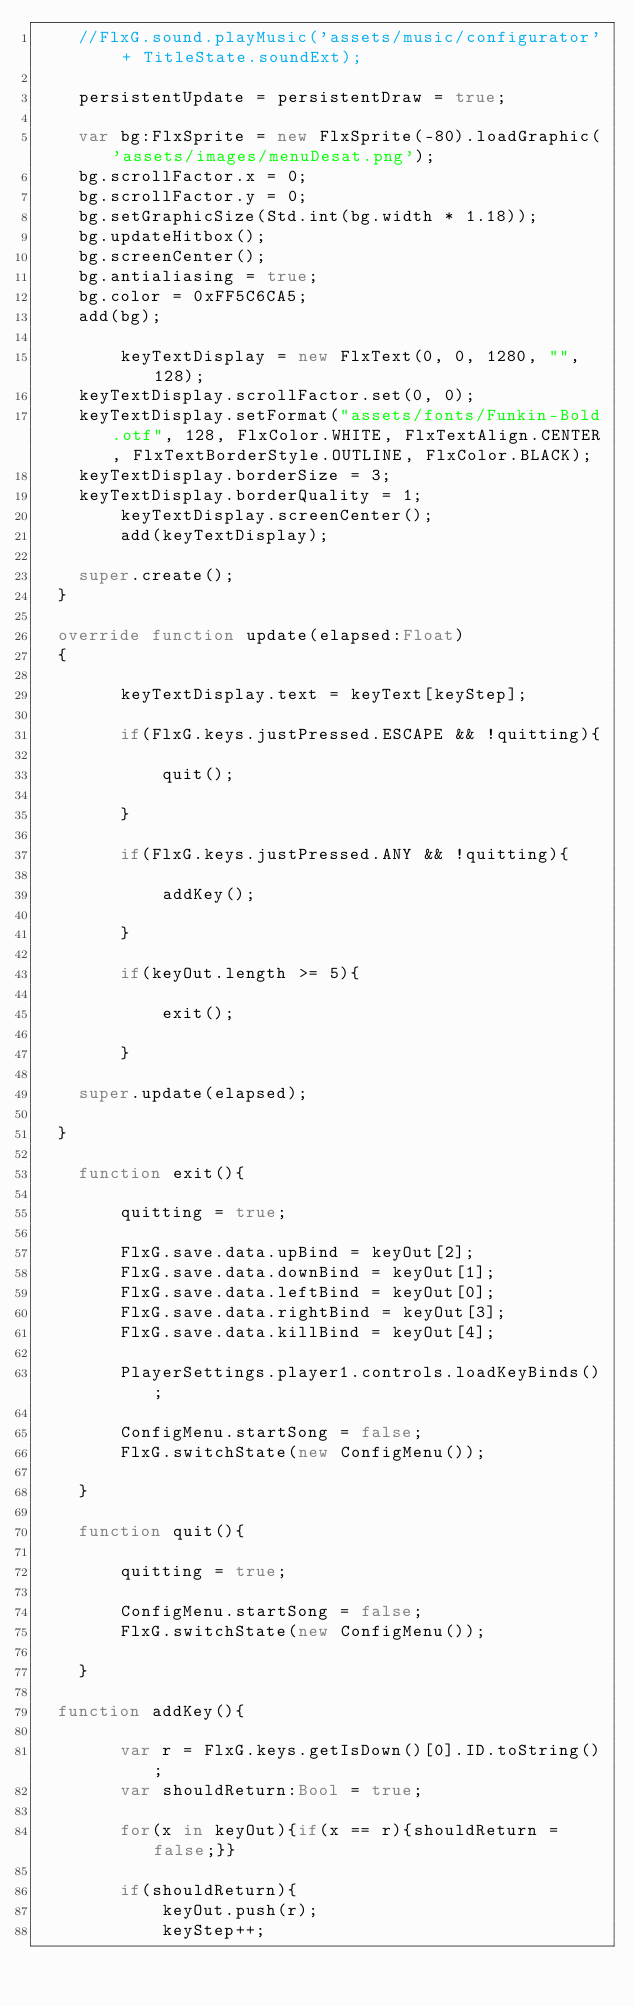<code> <loc_0><loc_0><loc_500><loc_500><_Haxe_>		//FlxG.sound.playMusic('assets/music/configurator' + TitleState.soundExt);

		persistentUpdate = persistentDraw = true;

		var bg:FlxSprite = new FlxSprite(-80).loadGraphic('assets/images/menuDesat.png');
		bg.scrollFactor.x = 0;
		bg.scrollFactor.y = 0;
		bg.setGraphicSize(Std.int(bg.width * 1.18));
		bg.updateHitbox();
		bg.screenCenter();
		bg.antialiasing = true;
		bg.color = 0xFF5C6CA5;
		add(bg);

        keyTextDisplay = new FlxText(0, 0, 1280, "", 128);
		keyTextDisplay.scrollFactor.set(0, 0);
		keyTextDisplay.setFormat("assets/fonts/Funkin-Bold.otf", 128, FlxColor.WHITE, FlxTextAlign.CENTER, FlxTextBorderStyle.OUTLINE, FlxColor.BLACK);
		keyTextDisplay.borderSize = 3;
		keyTextDisplay.borderQuality = 1;
        keyTextDisplay.screenCenter();
        add(keyTextDisplay);

		super.create();
	}

	override function update(elapsed:Float)
	{

        keyTextDisplay.text = keyText[keyStep];

        if(FlxG.keys.justPressed.ESCAPE && !quitting){

            quit();
            
        }

        if(FlxG.keys.justPressed.ANY && !quitting){

            addKey();
            
        }
        
        if(keyOut.length >= 5){

            exit();

        }

		super.update(elapsed);
		
	}

    function exit(){

        quitting = true;

        FlxG.save.data.upBind = keyOut[2];
        FlxG.save.data.downBind = keyOut[1];
        FlxG.save.data.leftBind = keyOut[0];
        FlxG.save.data.rightBind = keyOut[3];
        FlxG.save.data.killBind = keyOut[4];
        
        PlayerSettings.player1.controls.loadKeyBinds();

        ConfigMenu.startSong = false;
        FlxG.switchState(new ConfigMenu());

    }

    function quit(){

        quitting = true;

        ConfigMenu.startSong = false;
        FlxG.switchState(new ConfigMenu());

    }

	function addKey(){

        var r = FlxG.keys.getIsDown()[0].ID.toString();
        var shouldReturn:Bool = true;

        for(x in keyOut){if(x == r){shouldReturn = false;}}

        if(shouldReturn){
            keyOut.push(r);
            keyStep++;</code> 